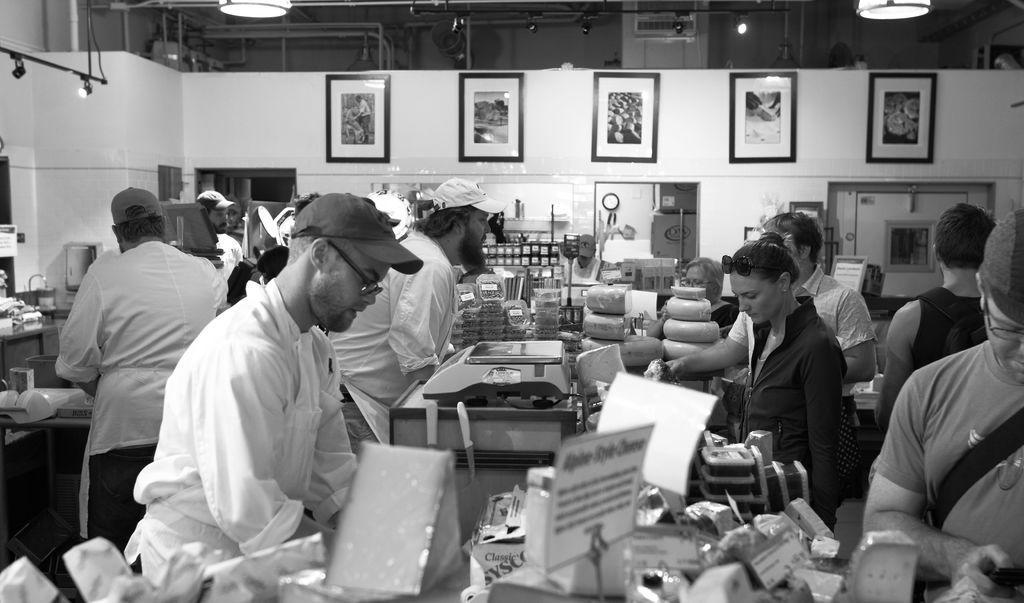How would you summarize this image in a sentence or two? In this image I can see the group of people standing and wearing the dresses. I can see few people with the caps. There are many objects and machines in-front of these people. In the background I can see many frames to the wall. I can also see the lights in the top. 